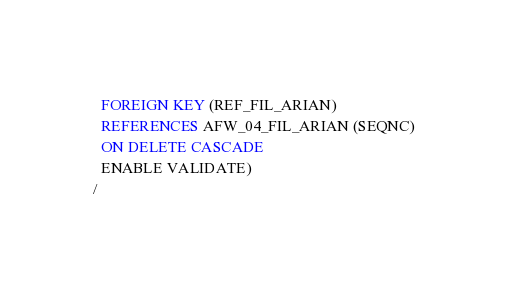Convert code to text. <code><loc_0><loc_0><loc_500><loc_500><_SQL_>  FOREIGN KEY (REF_FIL_ARIAN) 
  REFERENCES AFW_04_FIL_ARIAN (SEQNC)
  ON DELETE CASCADE
  ENABLE VALIDATE)
/
</code> 